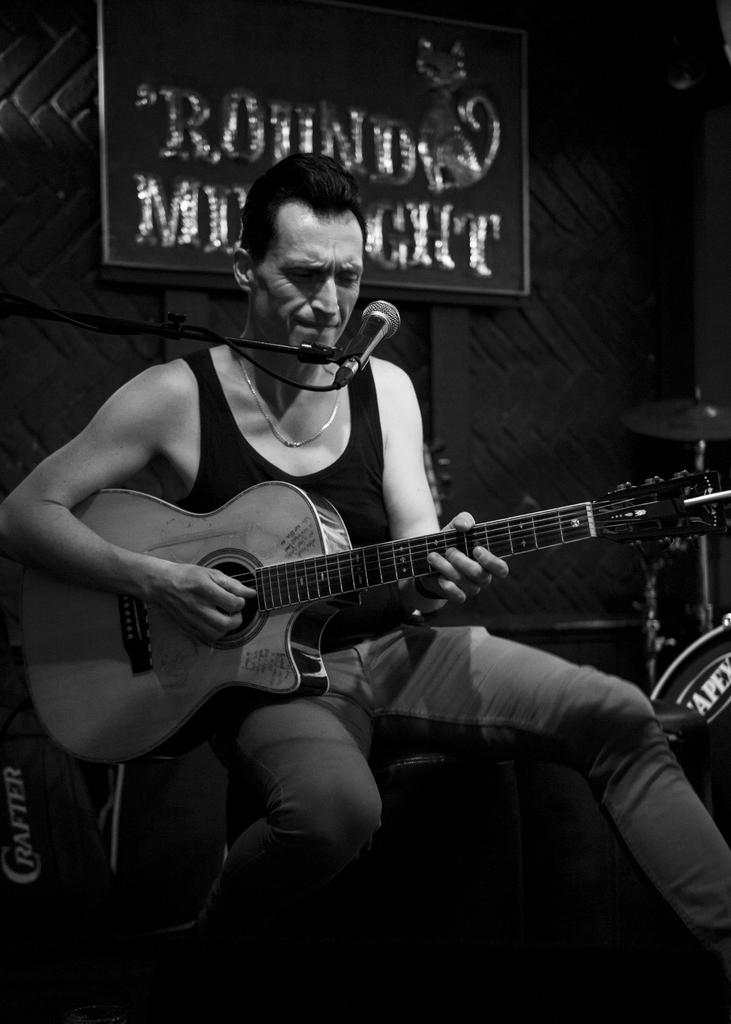What is the person in the image doing? The person is sitting and holding a guitar. What object is present that is commonly used for amplifying sound? There is a microphone with a stand in the image. What can be seen in the background of the image? There is a board and a wall visible in the background. What route does the person take to attend their class in the image? There is no information about a class or a route in the image; it only shows a person sitting with a guitar and a microphone with a stand. 